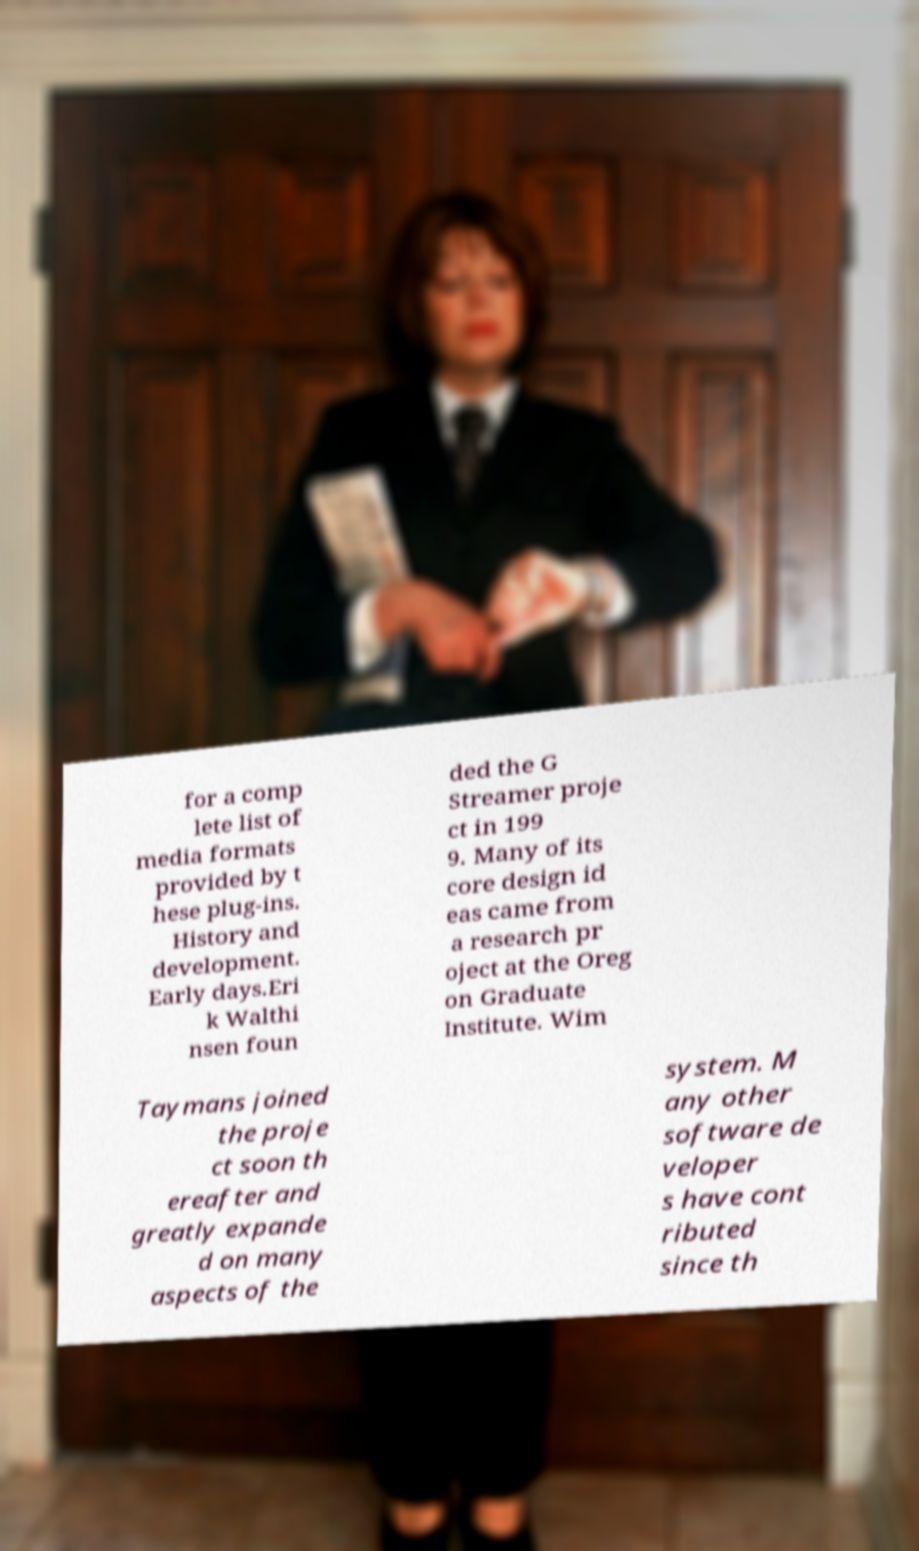What messages or text are displayed in this image? I need them in a readable, typed format. for a comp lete list of media formats provided by t hese plug-ins. History and development. Early days.Eri k Walthi nsen foun ded the G Streamer proje ct in 199 9. Many of its core design id eas came from a research pr oject at the Oreg on Graduate Institute. Wim Taymans joined the proje ct soon th ereafter and greatly expande d on many aspects of the system. M any other software de veloper s have cont ributed since th 